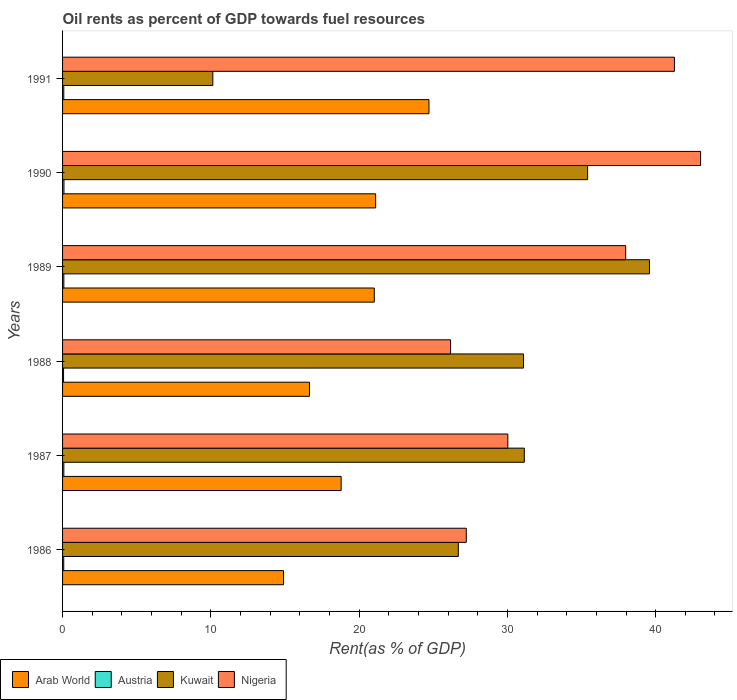How many groups of bars are there?
Your answer should be compact. 6. Are the number of bars per tick equal to the number of legend labels?
Provide a short and direct response. Yes. In how many cases, is the number of bars for a given year not equal to the number of legend labels?
Keep it short and to the point. 0. What is the oil rent in Arab World in 1990?
Make the answer very short. 21.11. Across all years, what is the maximum oil rent in Austria?
Give a very brief answer. 0.09. Across all years, what is the minimum oil rent in Nigeria?
Make the answer very short. 26.17. In which year was the oil rent in Nigeria minimum?
Your response must be concise. 1988. What is the total oil rent in Kuwait in the graph?
Ensure brevity in your answer.  174.04. What is the difference between the oil rent in Austria in 1986 and that in 1991?
Make the answer very short. -0. What is the difference between the oil rent in Kuwait in 1991 and the oil rent in Nigeria in 1989?
Offer a very short reply. -27.84. What is the average oil rent in Arab World per year?
Your response must be concise. 19.53. In the year 1986, what is the difference between the oil rent in Arab World and oil rent in Austria?
Provide a succinct answer. 14.82. What is the ratio of the oil rent in Kuwait in 1988 to that in 1991?
Ensure brevity in your answer.  3.07. Is the oil rent in Kuwait in 1988 less than that in 1991?
Make the answer very short. No. Is the difference between the oil rent in Arab World in 1987 and 1989 greater than the difference between the oil rent in Austria in 1987 and 1989?
Your response must be concise. No. What is the difference between the highest and the second highest oil rent in Kuwait?
Offer a very short reply. 4.17. What is the difference between the highest and the lowest oil rent in Nigeria?
Your response must be concise. 16.86. In how many years, is the oil rent in Austria greater than the average oil rent in Austria taken over all years?
Keep it short and to the point. 3. What does the 3rd bar from the top in 1990 represents?
Keep it short and to the point. Austria. What does the 4th bar from the bottom in 1988 represents?
Offer a terse response. Nigeria. Is it the case that in every year, the sum of the oil rent in Kuwait and oil rent in Austria is greater than the oil rent in Nigeria?
Ensure brevity in your answer.  No. How many bars are there?
Your answer should be very brief. 24. How many years are there in the graph?
Your answer should be very brief. 6. What is the difference between two consecutive major ticks on the X-axis?
Provide a short and direct response. 10. Does the graph contain any zero values?
Make the answer very short. No. Does the graph contain grids?
Ensure brevity in your answer.  No. How many legend labels are there?
Your answer should be very brief. 4. How are the legend labels stacked?
Your answer should be very brief. Horizontal. What is the title of the graph?
Offer a terse response. Oil rents as percent of GDP towards fuel resources. Does "Barbados" appear as one of the legend labels in the graph?
Offer a terse response. No. What is the label or title of the X-axis?
Offer a terse response. Rent(as % of GDP). What is the label or title of the Y-axis?
Ensure brevity in your answer.  Years. What is the Rent(as % of GDP) of Arab World in 1986?
Your response must be concise. 14.9. What is the Rent(as % of GDP) in Austria in 1986?
Your answer should be compact. 0.08. What is the Rent(as % of GDP) of Kuwait in 1986?
Your answer should be very brief. 26.69. What is the Rent(as % of GDP) in Nigeria in 1986?
Provide a short and direct response. 27.23. What is the Rent(as % of GDP) of Arab World in 1987?
Provide a short and direct response. 18.79. What is the Rent(as % of GDP) of Austria in 1987?
Give a very brief answer. 0.09. What is the Rent(as % of GDP) of Kuwait in 1987?
Make the answer very short. 31.14. What is the Rent(as % of GDP) of Nigeria in 1987?
Your answer should be compact. 30.03. What is the Rent(as % of GDP) in Arab World in 1988?
Your response must be concise. 16.65. What is the Rent(as % of GDP) of Austria in 1988?
Keep it short and to the point. 0.07. What is the Rent(as % of GDP) of Kuwait in 1988?
Keep it short and to the point. 31.09. What is the Rent(as % of GDP) of Nigeria in 1988?
Ensure brevity in your answer.  26.17. What is the Rent(as % of GDP) in Arab World in 1989?
Your response must be concise. 21.02. What is the Rent(as % of GDP) in Austria in 1989?
Offer a terse response. 0.09. What is the Rent(as % of GDP) in Kuwait in 1989?
Keep it short and to the point. 39.58. What is the Rent(as % of GDP) of Nigeria in 1989?
Give a very brief answer. 37.98. What is the Rent(as % of GDP) of Arab World in 1990?
Make the answer very short. 21.11. What is the Rent(as % of GDP) of Austria in 1990?
Your answer should be very brief. 0.09. What is the Rent(as % of GDP) of Kuwait in 1990?
Your response must be concise. 35.41. What is the Rent(as % of GDP) in Nigeria in 1990?
Give a very brief answer. 43.03. What is the Rent(as % of GDP) in Arab World in 1991?
Provide a succinct answer. 24.71. What is the Rent(as % of GDP) in Austria in 1991?
Provide a short and direct response. 0.08. What is the Rent(as % of GDP) of Kuwait in 1991?
Your answer should be very brief. 10.13. What is the Rent(as % of GDP) in Nigeria in 1991?
Provide a short and direct response. 41.27. Across all years, what is the maximum Rent(as % of GDP) of Arab World?
Keep it short and to the point. 24.71. Across all years, what is the maximum Rent(as % of GDP) in Austria?
Provide a short and direct response. 0.09. Across all years, what is the maximum Rent(as % of GDP) in Kuwait?
Keep it short and to the point. 39.58. Across all years, what is the maximum Rent(as % of GDP) in Nigeria?
Offer a terse response. 43.03. Across all years, what is the minimum Rent(as % of GDP) of Arab World?
Your response must be concise. 14.9. Across all years, what is the minimum Rent(as % of GDP) of Austria?
Your answer should be very brief. 0.07. Across all years, what is the minimum Rent(as % of GDP) in Kuwait?
Ensure brevity in your answer.  10.13. Across all years, what is the minimum Rent(as % of GDP) of Nigeria?
Provide a succinct answer. 26.17. What is the total Rent(as % of GDP) of Arab World in the graph?
Your response must be concise. 117.19. What is the total Rent(as % of GDP) of Austria in the graph?
Your answer should be very brief. 0.5. What is the total Rent(as % of GDP) of Kuwait in the graph?
Provide a short and direct response. 174.04. What is the total Rent(as % of GDP) of Nigeria in the graph?
Offer a very short reply. 205.7. What is the difference between the Rent(as % of GDP) of Arab World in 1986 and that in 1987?
Offer a terse response. -3.88. What is the difference between the Rent(as % of GDP) in Austria in 1986 and that in 1987?
Provide a succinct answer. -0.01. What is the difference between the Rent(as % of GDP) of Kuwait in 1986 and that in 1987?
Make the answer very short. -4.45. What is the difference between the Rent(as % of GDP) of Nigeria in 1986 and that in 1987?
Provide a short and direct response. -2.8. What is the difference between the Rent(as % of GDP) of Arab World in 1986 and that in 1988?
Provide a short and direct response. -1.75. What is the difference between the Rent(as % of GDP) in Austria in 1986 and that in 1988?
Your answer should be compact. 0.01. What is the difference between the Rent(as % of GDP) of Kuwait in 1986 and that in 1988?
Provide a short and direct response. -4.39. What is the difference between the Rent(as % of GDP) in Nigeria in 1986 and that in 1988?
Offer a terse response. 1.06. What is the difference between the Rent(as % of GDP) in Arab World in 1986 and that in 1989?
Provide a short and direct response. -6.12. What is the difference between the Rent(as % of GDP) of Austria in 1986 and that in 1989?
Keep it short and to the point. -0.01. What is the difference between the Rent(as % of GDP) of Kuwait in 1986 and that in 1989?
Offer a very short reply. -12.89. What is the difference between the Rent(as % of GDP) in Nigeria in 1986 and that in 1989?
Your answer should be compact. -10.75. What is the difference between the Rent(as % of GDP) of Arab World in 1986 and that in 1990?
Your answer should be very brief. -6.21. What is the difference between the Rent(as % of GDP) of Austria in 1986 and that in 1990?
Offer a terse response. -0.02. What is the difference between the Rent(as % of GDP) of Kuwait in 1986 and that in 1990?
Make the answer very short. -8.72. What is the difference between the Rent(as % of GDP) in Nigeria in 1986 and that in 1990?
Give a very brief answer. -15.8. What is the difference between the Rent(as % of GDP) of Arab World in 1986 and that in 1991?
Give a very brief answer. -9.81. What is the difference between the Rent(as % of GDP) of Austria in 1986 and that in 1991?
Give a very brief answer. -0. What is the difference between the Rent(as % of GDP) in Kuwait in 1986 and that in 1991?
Give a very brief answer. 16.56. What is the difference between the Rent(as % of GDP) in Nigeria in 1986 and that in 1991?
Keep it short and to the point. -14.04. What is the difference between the Rent(as % of GDP) of Arab World in 1987 and that in 1988?
Offer a terse response. 2.14. What is the difference between the Rent(as % of GDP) in Austria in 1987 and that in 1988?
Offer a very short reply. 0.02. What is the difference between the Rent(as % of GDP) in Kuwait in 1987 and that in 1988?
Your response must be concise. 0.06. What is the difference between the Rent(as % of GDP) of Nigeria in 1987 and that in 1988?
Offer a very short reply. 3.86. What is the difference between the Rent(as % of GDP) of Arab World in 1987 and that in 1989?
Make the answer very short. -2.24. What is the difference between the Rent(as % of GDP) of Kuwait in 1987 and that in 1989?
Provide a succinct answer. -8.44. What is the difference between the Rent(as % of GDP) of Nigeria in 1987 and that in 1989?
Your answer should be very brief. -7.95. What is the difference between the Rent(as % of GDP) in Arab World in 1987 and that in 1990?
Offer a terse response. -2.33. What is the difference between the Rent(as % of GDP) in Austria in 1987 and that in 1990?
Make the answer very short. -0.01. What is the difference between the Rent(as % of GDP) in Kuwait in 1987 and that in 1990?
Your answer should be very brief. -4.27. What is the difference between the Rent(as % of GDP) of Nigeria in 1987 and that in 1990?
Give a very brief answer. -13. What is the difference between the Rent(as % of GDP) in Arab World in 1987 and that in 1991?
Offer a very short reply. -5.92. What is the difference between the Rent(as % of GDP) of Austria in 1987 and that in 1991?
Your answer should be compact. 0. What is the difference between the Rent(as % of GDP) in Kuwait in 1987 and that in 1991?
Your answer should be very brief. 21.01. What is the difference between the Rent(as % of GDP) of Nigeria in 1987 and that in 1991?
Ensure brevity in your answer.  -11.24. What is the difference between the Rent(as % of GDP) of Arab World in 1988 and that in 1989?
Offer a terse response. -4.37. What is the difference between the Rent(as % of GDP) in Austria in 1988 and that in 1989?
Keep it short and to the point. -0.02. What is the difference between the Rent(as % of GDP) in Kuwait in 1988 and that in 1989?
Ensure brevity in your answer.  -8.5. What is the difference between the Rent(as % of GDP) in Nigeria in 1988 and that in 1989?
Keep it short and to the point. -11.81. What is the difference between the Rent(as % of GDP) in Arab World in 1988 and that in 1990?
Offer a very short reply. -4.46. What is the difference between the Rent(as % of GDP) in Austria in 1988 and that in 1990?
Offer a terse response. -0.03. What is the difference between the Rent(as % of GDP) of Kuwait in 1988 and that in 1990?
Your answer should be compact. -4.32. What is the difference between the Rent(as % of GDP) in Nigeria in 1988 and that in 1990?
Your answer should be very brief. -16.86. What is the difference between the Rent(as % of GDP) of Arab World in 1988 and that in 1991?
Your response must be concise. -8.06. What is the difference between the Rent(as % of GDP) in Austria in 1988 and that in 1991?
Ensure brevity in your answer.  -0.01. What is the difference between the Rent(as % of GDP) in Kuwait in 1988 and that in 1991?
Your answer should be very brief. 20.95. What is the difference between the Rent(as % of GDP) in Nigeria in 1988 and that in 1991?
Ensure brevity in your answer.  -15.1. What is the difference between the Rent(as % of GDP) of Arab World in 1989 and that in 1990?
Ensure brevity in your answer.  -0.09. What is the difference between the Rent(as % of GDP) in Austria in 1989 and that in 1990?
Offer a very short reply. -0.01. What is the difference between the Rent(as % of GDP) of Kuwait in 1989 and that in 1990?
Offer a very short reply. 4.17. What is the difference between the Rent(as % of GDP) in Nigeria in 1989 and that in 1990?
Your answer should be compact. -5.05. What is the difference between the Rent(as % of GDP) of Arab World in 1989 and that in 1991?
Your answer should be compact. -3.69. What is the difference between the Rent(as % of GDP) in Austria in 1989 and that in 1991?
Give a very brief answer. 0. What is the difference between the Rent(as % of GDP) in Kuwait in 1989 and that in 1991?
Provide a succinct answer. 29.45. What is the difference between the Rent(as % of GDP) of Nigeria in 1989 and that in 1991?
Offer a very short reply. -3.29. What is the difference between the Rent(as % of GDP) of Arab World in 1990 and that in 1991?
Give a very brief answer. -3.6. What is the difference between the Rent(as % of GDP) in Austria in 1990 and that in 1991?
Ensure brevity in your answer.  0.01. What is the difference between the Rent(as % of GDP) in Kuwait in 1990 and that in 1991?
Ensure brevity in your answer.  25.28. What is the difference between the Rent(as % of GDP) in Nigeria in 1990 and that in 1991?
Your response must be concise. 1.76. What is the difference between the Rent(as % of GDP) of Arab World in 1986 and the Rent(as % of GDP) of Austria in 1987?
Provide a short and direct response. 14.82. What is the difference between the Rent(as % of GDP) in Arab World in 1986 and the Rent(as % of GDP) in Kuwait in 1987?
Offer a very short reply. -16.24. What is the difference between the Rent(as % of GDP) of Arab World in 1986 and the Rent(as % of GDP) of Nigeria in 1987?
Give a very brief answer. -15.13. What is the difference between the Rent(as % of GDP) in Austria in 1986 and the Rent(as % of GDP) in Kuwait in 1987?
Make the answer very short. -31.06. What is the difference between the Rent(as % of GDP) in Austria in 1986 and the Rent(as % of GDP) in Nigeria in 1987?
Keep it short and to the point. -29.95. What is the difference between the Rent(as % of GDP) of Kuwait in 1986 and the Rent(as % of GDP) of Nigeria in 1987?
Provide a short and direct response. -3.34. What is the difference between the Rent(as % of GDP) in Arab World in 1986 and the Rent(as % of GDP) in Austria in 1988?
Your answer should be very brief. 14.83. What is the difference between the Rent(as % of GDP) of Arab World in 1986 and the Rent(as % of GDP) of Kuwait in 1988?
Your answer should be very brief. -16.18. What is the difference between the Rent(as % of GDP) in Arab World in 1986 and the Rent(as % of GDP) in Nigeria in 1988?
Keep it short and to the point. -11.27. What is the difference between the Rent(as % of GDP) of Austria in 1986 and the Rent(as % of GDP) of Kuwait in 1988?
Your answer should be very brief. -31.01. What is the difference between the Rent(as % of GDP) in Austria in 1986 and the Rent(as % of GDP) in Nigeria in 1988?
Offer a terse response. -26.09. What is the difference between the Rent(as % of GDP) in Kuwait in 1986 and the Rent(as % of GDP) in Nigeria in 1988?
Your response must be concise. 0.52. What is the difference between the Rent(as % of GDP) in Arab World in 1986 and the Rent(as % of GDP) in Austria in 1989?
Your answer should be very brief. 14.82. What is the difference between the Rent(as % of GDP) in Arab World in 1986 and the Rent(as % of GDP) in Kuwait in 1989?
Keep it short and to the point. -24.68. What is the difference between the Rent(as % of GDP) in Arab World in 1986 and the Rent(as % of GDP) in Nigeria in 1989?
Your answer should be compact. -23.08. What is the difference between the Rent(as % of GDP) in Austria in 1986 and the Rent(as % of GDP) in Kuwait in 1989?
Give a very brief answer. -39.5. What is the difference between the Rent(as % of GDP) of Austria in 1986 and the Rent(as % of GDP) of Nigeria in 1989?
Offer a terse response. -37.9. What is the difference between the Rent(as % of GDP) in Kuwait in 1986 and the Rent(as % of GDP) in Nigeria in 1989?
Offer a very short reply. -11.29. What is the difference between the Rent(as % of GDP) of Arab World in 1986 and the Rent(as % of GDP) of Austria in 1990?
Your response must be concise. 14.81. What is the difference between the Rent(as % of GDP) in Arab World in 1986 and the Rent(as % of GDP) in Kuwait in 1990?
Make the answer very short. -20.51. What is the difference between the Rent(as % of GDP) in Arab World in 1986 and the Rent(as % of GDP) in Nigeria in 1990?
Ensure brevity in your answer.  -28.13. What is the difference between the Rent(as % of GDP) of Austria in 1986 and the Rent(as % of GDP) of Kuwait in 1990?
Your answer should be compact. -35.33. What is the difference between the Rent(as % of GDP) in Austria in 1986 and the Rent(as % of GDP) in Nigeria in 1990?
Keep it short and to the point. -42.95. What is the difference between the Rent(as % of GDP) of Kuwait in 1986 and the Rent(as % of GDP) of Nigeria in 1990?
Offer a terse response. -16.34. What is the difference between the Rent(as % of GDP) of Arab World in 1986 and the Rent(as % of GDP) of Austria in 1991?
Your answer should be compact. 14.82. What is the difference between the Rent(as % of GDP) in Arab World in 1986 and the Rent(as % of GDP) in Kuwait in 1991?
Provide a succinct answer. 4.77. What is the difference between the Rent(as % of GDP) in Arab World in 1986 and the Rent(as % of GDP) in Nigeria in 1991?
Ensure brevity in your answer.  -26.36. What is the difference between the Rent(as % of GDP) in Austria in 1986 and the Rent(as % of GDP) in Kuwait in 1991?
Your answer should be compact. -10.05. What is the difference between the Rent(as % of GDP) of Austria in 1986 and the Rent(as % of GDP) of Nigeria in 1991?
Ensure brevity in your answer.  -41.19. What is the difference between the Rent(as % of GDP) of Kuwait in 1986 and the Rent(as % of GDP) of Nigeria in 1991?
Offer a terse response. -14.57. What is the difference between the Rent(as % of GDP) of Arab World in 1987 and the Rent(as % of GDP) of Austria in 1988?
Keep it short and to the point. 18.72. What is the difference between the Rent(as % of GDP) in Arab World in 1987 and the Rent(as % of GDP) in Kuwait in 1988?
Provide a succinct answer. -12.3. What is the difference between the Rent(as % of GDP) in Arab World in 1987 and the Rent(as % of GDP) in Nigeria in 1988?
Your answer should be compact. -7.38. What is the difference between the Rent(as % of GDP) of Austria in 1987 and the Rent(as % of GDP) of Kuwait in 1988?
Ensure brevity in your answer.  -31. What is the difference between the Rent(as % of GDP) in Austria in 1987 and the Rent(as % of GDP) in Nigeria in 1988?
Provide a short and direct response. -26.08. What is the difference between the Rent(as % of GDP) in Kuwait in 1987 and the Rent(as % of GDP) in Nigeria in 1988?
Offer a terse response. 4.97. What is the difference between the Rent(as % of GDP) in Arab World in 1987 and the Rent(as % of GDP) in Austria in 1989?
Provide a short and direct response. 18.7. What is the difference between the Rent(as % of GDP) of Arab World in 1987 and the Rent(as % of GDP) of Kuwait in 1989?
Offer a terse response. -20.8. What is the difference between the Rent(as % of GDP) in Arab World in 1987 and the Rent(as % of GDP) in Nigeria in 1989?
Your answer should be very brief. -19.19. What is the difference between the Rent(as % of GDP) of Austria in 1987 and the Rent(as % of GDP) of Kuwait in 1989?
Offer a terse response. -39.5. What is the difference between the Rent(as % of GDP) in Austria in 1987 and the Rent(as % of GDP) in Nigeria in 1989?
Ensure brevity in your answer.  -37.89. What is the difference between the Rent(as % of GDP) in Kuwait in 1987 and the Rent(as % of GDP) in Nigeria in 1989?
Your response must be concise. -6.84. What is the difference between the Rent(as % of GDP) in Arab World in 1987 and the Rent(as % of GDP) in Austria in 1990?
Keep it short and to the point. 18.69. What is the difference between the Rent(as % of GDP) in Arab World in 1987 and the Rent(as % of GDP) in Kuwait in 1990?
Offer a very short reply. -16.62. What is the difference between the Rent(as % of GDP) of Arab World in 1987 and the Rent(as % of GDP) of Nigeria in 1990?
Keep it short and to the point. -24.24. What is the difference between the Rent(as % of GDP) of Austria in 1987 and the Rent(as % of GDP) of Kuwait in 1990?
Keep it short and to the point. -35.32. What is the difference between the Rent(as % of GDP) of Austria in 1987 and the Rent(as % of GDP) of Nigeria in 1990?
Give a very brief answer. -42.94. What is the difference between the Rent(as % of GDP) in Kuwait in 1987 and the Rent(as % of GDP) in Nigeria in 1990?
Offer a very short reply. -11.89. What is the difference between the Rent(as % of GDP) in Arab World in 1987 and the Rent(as % of GDP) in Austria in 1991?
Offer a terse response. 18.71. What is the difference between the Rent(as % of GDP) of Arab World in 1987 and the Rent(as % of GDP) of Kuwait in 1991?
Provide a short and direct response. 8.65. What is the difference between the Rent(as % of GDP) of Arab World in 1987 and the Rent(as % of GDP) of Nigeria in 1991?
Your answer should be compact. -22.48. What is the difference between the Rent(as % of GDP) in Austria in 1987 and the Rent(as % of GDP) in Kuwait in 1991?
Make the answer very short. -10.05. What is the difference between the Rent(as % of GDP) of Austria in 1987 and the Rent(as % of GDP) of Nigeria in 1991?
Provide a short and direct response. -41.18. What is the difference between the Rent(as % of GDP) in Kuwait in 1987 and the Rent(as % of GDP) in Nigeria in 1991?
Offer a very short reply. -10.12. What is the difference between the Rent(as % of GDP) of Arab World in 1988 and the Rent(as % of GDP) of Austria in 1989?
Your response must be concise. 16.57. What is the difference between the Rent(as % of GDP) in Arab World in 1988 and the Rent(as % of GDP) in Kuwait in 1989?
Offer a terse response. -22.93. What is the difference between the Rent(as % of GDP) of Arab World in 1988 and the Rent(as % of GDP) of Nigeria in 1989?
Ensure brevity in your answer.  -21.33. What is the difference between the Rent(as % of GDP) of Austria in 1988 and the Rent(as % of GDP) of Kuwait in 1989?
Give a very brief answer. -39.51. What is the difference between the Rent(as % of GDP) of Austria in 1988 and the Rent(as % of GDP) of Nigeria in 1989?
Your answer should be very brief. -37.91. What is the difference between the Rent(as % of GDP) in Kuwait in 1988 and the Rent(as % of GDP) in Nigeria in 1989?
Your answer should be very brief. -6.89. What is the difference between the Rent(as % of GDP) in Arab World in 1988 and the Rent(as % of GDP) in Austria in 1990?
Give a very brief answer. 16.56. What is the difference between the Rent(as % of GDP) in Arab World in 1988 and the Rent(as % of GDP) in Kuwait in 1990?
Give a very brief answer. -18.76. What is the difference between the Rent(as % of GDP) of Arab World in 1988 and the Rent(as % of GDP) of Nigeria in 1990?
Provide a succinct answer. -26.38. What is the difference between the Rent(as % of GDP) of Austria in 1988 and the Rent(as % of GDP) of Kuwait in 1990?
Give a very brief answer. -35.34. What is the difference between the Rent(as % of GDP) in Austria in 1988 and the Rent(as % of GDP) in Nigeria in 1990?
Your answer should be compact. -42.96. What is the difference between the Rent(as % of GDP) of Kuwait in 1988 and the Rent(as % of GDP) of Nigeria in 1990?
Your answer should be very brief. -11.94. What is the difference between the Rent(as % of GDP) in Arab World in 1988 and the Rent(as % of GDP) in Austria in 1991?
Provide a succinct answer. 16.57. What is the difference between the Rent(as % of GDP) in Arab World in 1988 and the Rent(as % of GDP) in Kuwait in 1991?
Provide a succinct answer. 6.52. What is the difference between the Rent(as % of GDP) in Arab World in 1988 and the Rent(as % of GDP) in Nigeria in 1991?
Offer a terse response. -24.61. What is the difference between the Rent(as % of GDP) of Austria in 1988 and the Rent(as % of GDP) of Kuwait in 1991?
Offer a very short reply. -10.07. What is the difference between the Rent(as % of GDP) of Austria in 1988 and the Rent(as % of GDP) of Nigeria in 1991?
Your response must be concise. -41.2. What is the difference between the Rent(as % of GDP) in Kuwait in 1988 and the Rent(as % of GDP) in Nigeria in 1991?
Offer a terse response. -10.18. What is the difference between the Rent(as % of GDP) of Arab World in 1989 and the Rent(as % of GDP) of Austria in 1990?
Your answer should be compact. 20.93. What is the difference between the Rent(as % of GDP) of Arab World in 1989 and the Rent(as % of GDP) of Kuwait in 1990?
Your response must be concise. -14.39. What is the difference between the Rent(as % of GDP) of Arab World in 1989 and the Rent(as % of GDP) of Nigeria in 1990?
Ensure brevity in your answer.  -22.01. What is the difference between the Rent(as % of GDP) of Austria in 1989 and the Rent(as % of GDP) of Kuwait in 1990?
Your response must be concise. -35.32. What is the difference between the Rent(as % of GDP) of Austria in 1989 and the Rent(as % of GDP) of Nigeria in 1990?
Give a very brief answer. -42.94. What is the difference between the Rent(as % of GDP) of Kuwait in 1989 and the Rent(as % of GDP) of Nigeria in 1990?
Provide a succinct answer. -3.45. What is the difference between the Rent(as % of GDP) of Arab World in 1989 and the Rent(as % of GDP) of Austria in 1991?
Your answer should be compact. 20.94. What is the difference between the Rent(as % of GDP) of Arab World in 1989 and the Rent(as % of GDP) of Kuwait in 1991?
Give a very brief answer. 10.89. What is the difference between the Rent(as % of GDP) of Arab World in 1989 and the Rent(as % of GDP) of Nigeria in 1991?
Provide a short and direct response. -20.24. What is the difference between the Rent(as % of GDP) of Austria in 1989 and the Rent(as % of GDP) of Kuwait in 1991?
Make the answer very short. -10.05. What is the difference between the Rent(as % of GDP) in Austria in 1989 and the Rent(as % of GDP) in Nigeria in 1991?
Provide a short and direct response. -41.18. What is the difference between the Rent(as % of GDP) in Kuwait in 1989 and the Rent(as % of GDP) in Nigeria in 1991?
Your response must be concise. -1.68. What is the difference between the Rent(as % of GDP) in Arab World in 1990 and the Rent(as % of GDP) in Austria in 1991?
Ensure brevity in your answer.  21.03. What is the difference between the Rent(as % of GDP) of Arab World in 1990 and the Rent(as % of GDP) of Kuwait in 1991?
Offer a terse response. 10.98. What is the difference between the Rent(as % of GDP) in Arab World in 1990 and the Rent(as % of GDP) in Nigeria in 1991?
Ensure brevity in your answer.  -20.15. What is the difference between the Rent(as % of GDP) of Austria in 1990 and the Rent(as % of GDP) of Kuwait in 1991?
Your answer should be compact. -10.04. What is the difference between the Rent(as % of GDP) in Austria in 1990 and the Rent(as % of GDP) in Nigeria in 1991?
Provide a succinct answer. -41.17. What is the difference between the Rent(as % of GDP) in Kuwait in 1990 and the Rent(as % of GDP) in Nigeria in 1991?
Give a very brief answer. -5.86. What is the average Rent(as % of GDP) of Arab World per year?
Ensure brevity in your answer.  19.53. What is the average Rent(as % of GDP) of Austria per year?
Your answer should be very brief. 0.08. What is the average Rent(as % of GDP) of Kuwait per year?
Give a very brief answer. 29.01. What is the average Rent(as % of GDP) of Nigeria per year?
Your response must be concise. 34.28. In the year 1986, what is the difference between the Rent(as % of GDP) of Arab World and Rent(as % of GDP) of Austria?
Provide a succinct answer. 14.82. In the year 1986, what is the difference between the Rent(as % of GDP) in Arab World and Rent(as % of GDP) in Kuwait?
Make the answer very short. -11.79. In the year 1986, what is the difference between the Rent(as % of GDP) of Arab World and Rent(as % of GDP) of Nigeria?
Provide a succinct answer. -12.32. In the year 1986, what is the difference between the Rent(as % of GDP) in Austria and Rent(as % of GDP) in Kuwait?
Your response must be concise. -26.61. In the year 1986, what is the difference between the Rent(as % of GDP) of Austria and Rent(as % of GDP) of Nigeria?
Your response must be concise. -27.15. In the year 1986, what is the difference between the Rent(as % of GDP) of Kuwait and Rent(as % of GDP) of Nigeria?
Give a very brief answer. -0.54. In the year 1987, what is the difference between the Rent(as % of GDP) of Arab World and Rent(as % of GDP) of Austria?
Make the answer very short. 18.7. In the year 1987, what is the difference between the Rent(as % of GDP) of Arab World and Rent(as % of GDP) of Kuwait?
Your answer should be very brief. -12.35. In the year 1987, what is the difference between the Rent(as % of GDP) in Arab World and Rent(as % of GDP) in Nigeria?
Your answer should be compact. -11.24. In the year 1987, what is the difference between the Rent(as % of GDP) in Austria and Rent(as % of GDP) in Kuwait?
Your answer should be compact. -31.05. In the year 1987, what is the difference between the Rent(as % of GDP) of Austria and Rent(as % of GDP) of Nigeria?
Your answer should be very brief. -29.94. In the year 1987, what is the difference between the Rent(as % of GDP) in Kuwait and Rent(as % of GDP) in Nigeria?
Make the answer very short. 1.11. In the year 1988, what is the difference between the Rent(as % of GDP) of Arab World and Rent(as % of GDP) of Austria?
Make the answer very short. 16.58. In the year 1988, what is the difference between the Rent(as % of GDP) in Arab World and Rent(as % of GDP) in Kuwait?
Ensure brevity in your answer.  -14.44. In the year 1988, what is the difference between the Rent(as % of GDP) of Arab World and Rent(as % of GDP) of Nigeria?
Provide a short and direct response. -9.52. In the year 1988, what is the difference between the Rent(as % of GDP) of Austria and Rent(as % of GDP) of Kuwait?
Provide a succinct answer. -31.02. In the year 1988, what is the difference between the Rent(as % of GDP) in Austria and Rent(as % of GDP) in Nigeria?
Ensure brevity in your answer.  -26.1. In the year 1988, what is the difference between the Rent(as % of GDP) in Kuwait and Rent(as % of GDP) in Nigeria?
Offer a terse response. 4.92. In the year 1989, what is the difference between the Rent(as % of GDP) in Arab World and Rent(as % of GDP) in Austria?
Give a very brief answer. 20.94. In the year 1989, what is the difference between the Rent(as % of GDP) in Arab World and Rent(as % of GDP) in Kuwait?
Offer a terse response. -18.56. In the year 1989, what is the difference between the Rent(as % of GDP) of Arab World and Rent(as % of GDP) of Nigeria?
Your answer should be compact. -16.95. In the year 1989, what is the difference between the Rent(as % of GDP) of Austria and Rent(as % of GDP) of Kuwait?
Your answer should be compact. -39.5. In the year 1989, what is the difference between the Rent(as % of GDP) of Austria and Rent(as % of GDP) of Nigeria?
Your answer should be compact. -37.89. In the year 1989, what is the difference between the Rent(as % of GDP) in Kuwait and Rent(as % of GDP) in Nigeria?
Provide a succinct answer. 1.6. In the year 1990, what is the difference between the Rent(as % of GDP) in Arab World and Rent(as % of GDP) in Austria?
Offer a very short reply. 21.02. In the year 1990, what is the difference between the Rent(as % of GDP) of Arab World and Rent(as % of GDP) of Kuwait?
Offer a terse response. -14.3. In the year 1990, what is the difference between the Rent(as % of GDP) of Arab World and Rent(as % of GDP) of Nigeria?
Give a very brief answer. -21.91. In the year 1990, what is the difference between the Rent(as % of GDP) in Austria and Rent(as % of GDP) in Kuwait?
Keep it short and to the point. -35.32. In the year 1990, what is the difference between the Rent(as % of GDP) of Austria and Rent(as % of GDP) of Nigeria?
Your answer should be very brief. -42.93. In the year 1990, what is the difference between the Rent(as % of GDP) in Kuwait and Rent(as % of GDP) in Nigeria?
Your answer should be very brief. -7.62. In the year 1991, what is the difference between the Rent(as % of GDP) in Arab World and Rent(as % of GDP) in Austria?
Ensure brevity in your answer.  24.63. In the year 1991, what is the difference between the Rent(as % of GDP) in Arab World and Rent(as % of GDP) in Kuwait?
Ensure brevity in your answer.  14.58. In the year 1991, what is the difference between the Rent(as % of GDP) of Arab World and Rent(as % of GDP) of Nigeria?
Keep it short and to the point. -16.55. In the year 1991, what is the difference between the Rent(as % of GDP) in Austria and Rent(as % of GDP) in Kuwait?
Your answer should be compact. -10.05. In the year 1991, what is the difference between the Rent(as % of GDP) of Austria and Rent(as % of GDP) of Nigeria?
Your response must be concise. -41.18. In the year 1991, what is the difference between the Rent(as % of GDP) of Kuwait and Rent(as % of GDP) of Nigeria?
Provide a succinct answer. -31.13. What is the ratio of the Rent(as % of GDP) in Arab World in 1986 to that in 1987?
Provide a succinct answer. 0.79. What is the ratio of the Rent(as % of GDP) in Austria in 1986 to that in 1987?
Provide a short and direct response. 0.92. What is the ratio of the Rent(as % of GDP) in Kuwait in 1986 to that in 1987?
Offer a very short reply. 0.86. What is the ratio of the Rent(as % of GDP) in Nigeria in 1986 to that in 1987?
Offer a very short reply. 0.91. What is the ratio of the Rent(as % of GDP) in Arab World in 1986 to that in 1988?
Give a very brief answer. 0.9. What is the ratio of the Rent(as % of GDP) in Austria in 1986 to that in 1988?
Provide a short and direct response. 1.18. What is the ratio of the Rent(as % of GDP) of Kuwait in 1986 to that in 1988?
Your response must be concise. 0.86. What is the ratio of the Rent(as % of GDP) of Nigeria in 1986 to that in 1988?
Ensure brevity in your answer.  1.04. What is the ratio of the Rent(as % of GDP) in Arab World in 1986 to that in 1989?
Offer a terse response. 0.71. What is the ratio of the Rent(as % of GDP) in Austria in 1986 to that in 1989?
Ensure brevity in your answer.  0.92. What is the ratio of the Rent(as % of GDP) in Kuwait in 1986 to that in 1989?
Give a very brief answer. 0.67. What is the ratio of the Rent(as % of GDP) in Nigeria in 1986 to that in 1989?
Ensure brevity in your answer.  0.72. What is the ratio of the Rent(as % of GDP) of Arab World in 1986 to that in 1990?
Provide a short and direct response. 0.71. What is the ratio of the Rent(as % of GDP) of Austria in 1986 to that in 1990?
Ensure brevity in your answer.  0.83. What is the ratio of the Rent(as % of GDP) of Kuwait in 1986 to that in 1990?
Ensure brevity in your answer.  0.75. What is the ratio of the Rent(as % of GDP) in Nigeria in 1986 to that in 1990?
Your response must be concise. 0.63. What is the ratio of the Rent(as % of GDP) of Arab World in 1986 to that in 1991?
Offer a terse response. 0.6. What is the ratio of the Rent(as % of GDP) of Austria in 1986 to that in 1991?
Give a very brief answer. 0.97. What is the ratio of the Rent(as % of GDP) of Kuwait in 1986 to that in 1991?
Your response must be concise. 2.63. What is the ratio of the Rent(as % of GDP) of Nigeria in 1986 to that in 1991?
Provide a succinct answer. 0.66. What is the ratio of the Rent(as % of GDP) of Arab World in 1987 to that in 1988?
Your answer should be compact. 1.13. What is the ratio of the Rent(as % of GDP) in Austria in 1987 to that in 1988?
Give a very brief answer. 1.29. What is the ratio of the Rent(as % of GDP) in Kuwait in 1987 to that in 1988?
Provide a short and direct response. 1. What is the ratio of the Rent(as % of GDP) in Nigeria in 1987 to that in 1988?
Provide a succinct answer. 1.15. What is the ratio of the Rent(as % of GDP) in Arab World in 1987 to that in 1989?
Ensure brevity in your answer.  0.89. What is the ratio of the Rent(as % of GDP) of Kuwait in 1987 to that in 1989?
Your answer should be compact. 0.79. What is the ratio of the Rent(as % of GDP) in Nigeria in 1987 to that in 1989?
Your response must be concise. 0.79. What is the ratio of the Rent(as % of GDP) of Arab World in 1987 to that in 1990?
Make the answer very short. 0.89. What is the ratio of the Rent(as % of GDP) in Austria in 1987 to that in 1990?
Offer a terse response. 0.91. What is the ratio of the Rent(as % of GDP) in Kuwait in 1987 to that in 1990?
Make the answer very short. 0.88. What is the ratio of the Rent(as % of GDP) of Nigeria in 1987 to that in 1990?
Provide a succinct answer. 0.7. What is the ratio of the Rent(as % of GDP) of Arab World in 1987 to that in 1991?
Your answer should be compact. 0.76. What is the ratio of the Rent(as % of GDP) in Austria in 1987 to that in 1991?
Your response must be concise. 1.06. What is the ratio of the Rent(as % of GDP) in Kuwait in 1987 to that in 1991?
Offer a terse response. 3.07. What is the ratio of the Rent(as % of GDP) of Nigeria in 1987 to that in 1991?
Make the answer very short. 0.73. What is the ratio of the Rent(as % of GDP) of Arab World in 1988 to that in 1989?
Provide a succinct answer. 0.79. What is the ratio of the Rent(as % of GDP) in Austria in 1988 to that in 1989?
Offer a very short reply. 0.78. What is the ratio of the Rent(as % of GDP) of Kuwait in 1988 to that in 1989?
Keep it short and to the point. 0.79. What is the ratio of the Rent(as % of GDP) in Nigeria in 1988 to that in 1989?
Your answer should be compact. 0.69. What is the ratio of the Rent(as % of GDP) in Arab World in 1988 to that in 1990?
Provide a short and direct response. 0.79. What is the ratio of the Rent(as % of GDP) in Austria in 1988 to that in 1990?
Make the answer very short. 0.71. What is the ratio of the Rent(as % of GDP) of Kuwait in 1988 to that in 1990?
Keep it short and to the point. 0.88. What is the ratio of the Rent(as % of GDP) of Nigeria in 1988 to that in 1990?
Your response must be concise. 0.61. What is the ratio of the Rent(as % of GDP) in Arab World in 1988 to that in 1991?
Offer a very short reply. 0.67. What is the ratio of the Rent(as % of GDP) in Austria in 1988 to that in 1991?
Your answer should be compact. 0.82. What is the ratio of the Rent(as % of GDP) of Kuwait in 1988 to that in 1991?
Offer a terse response. 3.07. What is the ratio of the Rent(as % of GDP) in Nigeria in 1988 to that in 1991?
Your answer should be compact. 0.63. What is the ratio of the Rent(as % of GDP) of Arab World in 1989 to that in 1990?
Ensure brevity in your answer.  1. What is the ratio of the Rent(as % of GDP) of Austria in 1989 to that in 1990?
Give a very brief answer. 0.91. What is the ratio of the Rent(as % of GDP) of Kuwait in 1989 to that in 1990?
Keep it short and to the point. 1.12. What is the ratio of the Rent(as % of GDP) of Nigeria in 1989 to that in 1990?
Your response must be concise. 0.88. What is the ratio of the Rent(as % of GDP) in Arab World in 1989 to that in 1991?
Your response must be concise. 0.85. What is the ratio of the Rent(as % of GDP) of Austria in 1989 to that in 1991?
Give a very brief answer. 1.05. What is the ratio of the Rent(as % of GDP) of Kuwait in 1989 to that in 1991?
Ensure brevity in your answer.  3.91. What is the ratio of the Rent(as % of GDP) of Nigeria in 1989 to that in 1991?
Offer a terse response. 0.92. What is the ratio of the Rent(as % of GDP) in Arab World in 1990 to that in 1991?
Your answer should be compact. 0.85. What is the ratio of the Rent(as % of GDP) in Austria in 1990 to that in 1991?
Your answer should be very brief. 1.16. What is the ratio of the Rent(as % of GDP) of Kuwait in 1990 to that in 1991?
Give a very brief answer. 3.49. What is the ratio of the Rent(as % of GDP) in Nigeria in 1990 to that in 1991?
Your answer should be compact. 1.04. What is the difference between the highest and the second highest Rent(as % of GDP) of Arab World?
Provide a short and direct response. 3.6. What is the difference between the highest and the second highest Rent(as % of GDP) of Austria?
Keep it short and to the point. 0.01. What is the difference between the highest and the second highest Rent(as % of GDP) in Kuwait?
Keep it short and to the point. 4.17. What is the difference between the highest and the second highest Rent(as % of GDP) in Nigeria?
Offer a terse response. 1.76. What is the difference between the highest and the lowest Rent(as % of GDP) in Arab World?
Your response must be concise. 9.81. What is the difference between the highest and the lowest Rent(as % of GDP) in Austria?
Ensure brevity in your answer.  0.03. What is the difference between the highest and the lowest Rent(as % of GDP) of Kuwait?
Give a very brief answer. 29.45. What is the difference between the highest and the lowest Rent(as % of GDP) of Nigeria?
Ensure brevity in your answer.  16.86. 